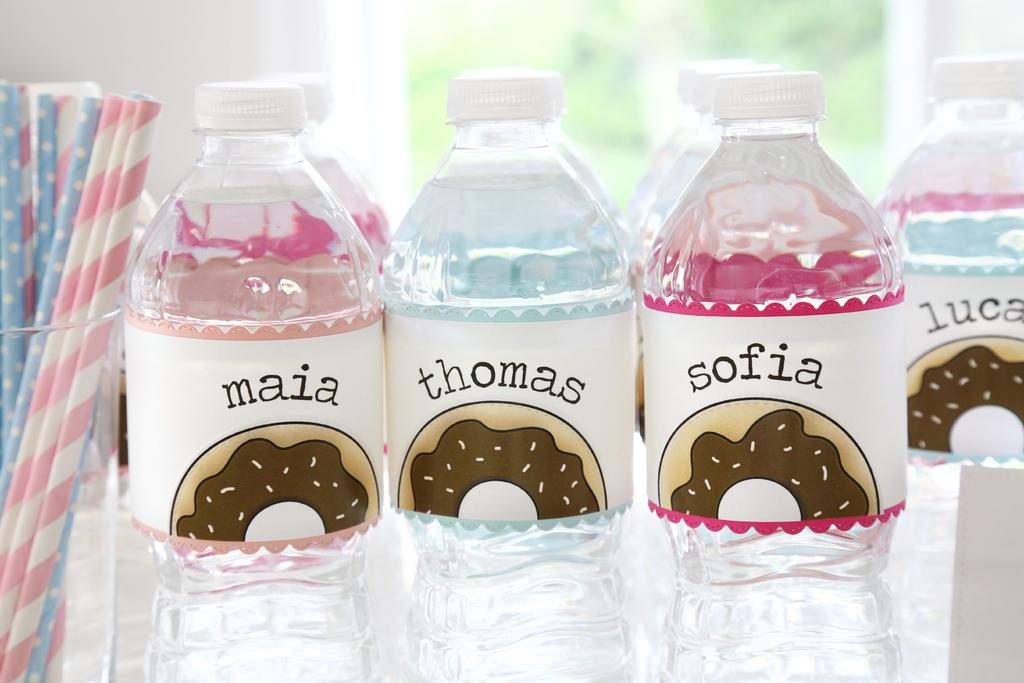<image>
Share a concise interpretation of the image provided. Bottles of water are imprinted with various names, including Thomas and Sofia. 